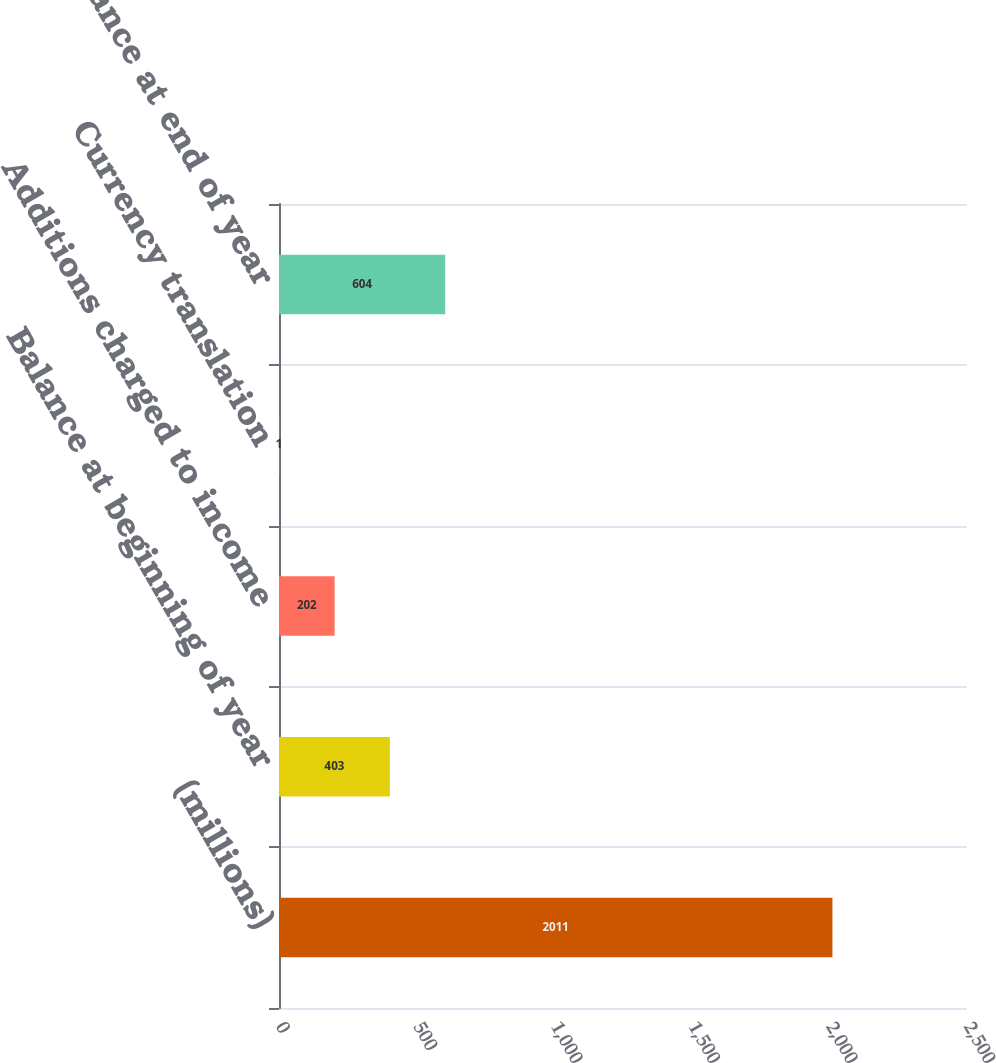<chart> <loc_0><loc_0><loc_500><loc_500><bar_chart><fcel>(millions)<fcel>Balance at beginning of year<fcel>Additions charged to income<fcel>Currency translation<fcel>Balance at end of year<nl><fcel>2011<fcel>403<fcel>202<fcel>1<fcel>604<nl></chart> 